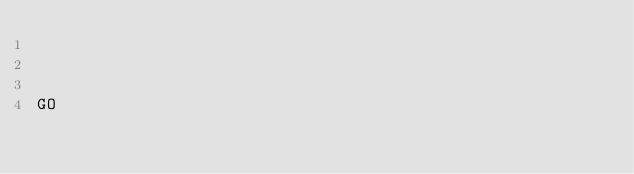<code> <loc_0><loc_0><loc_500><loc_500><_SQL_>


GO</code> 